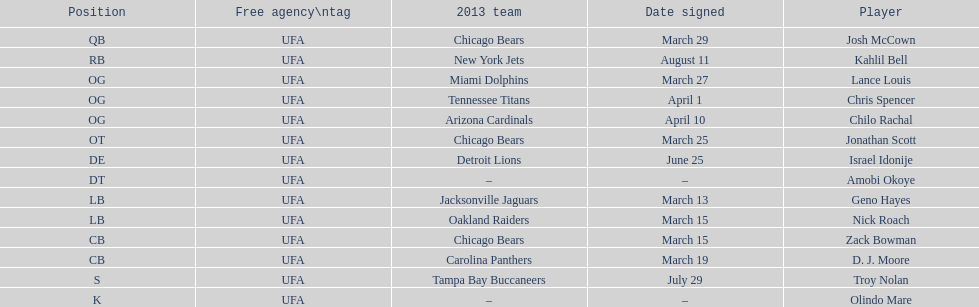What is the total of 2013 teams on the chart? 10. 